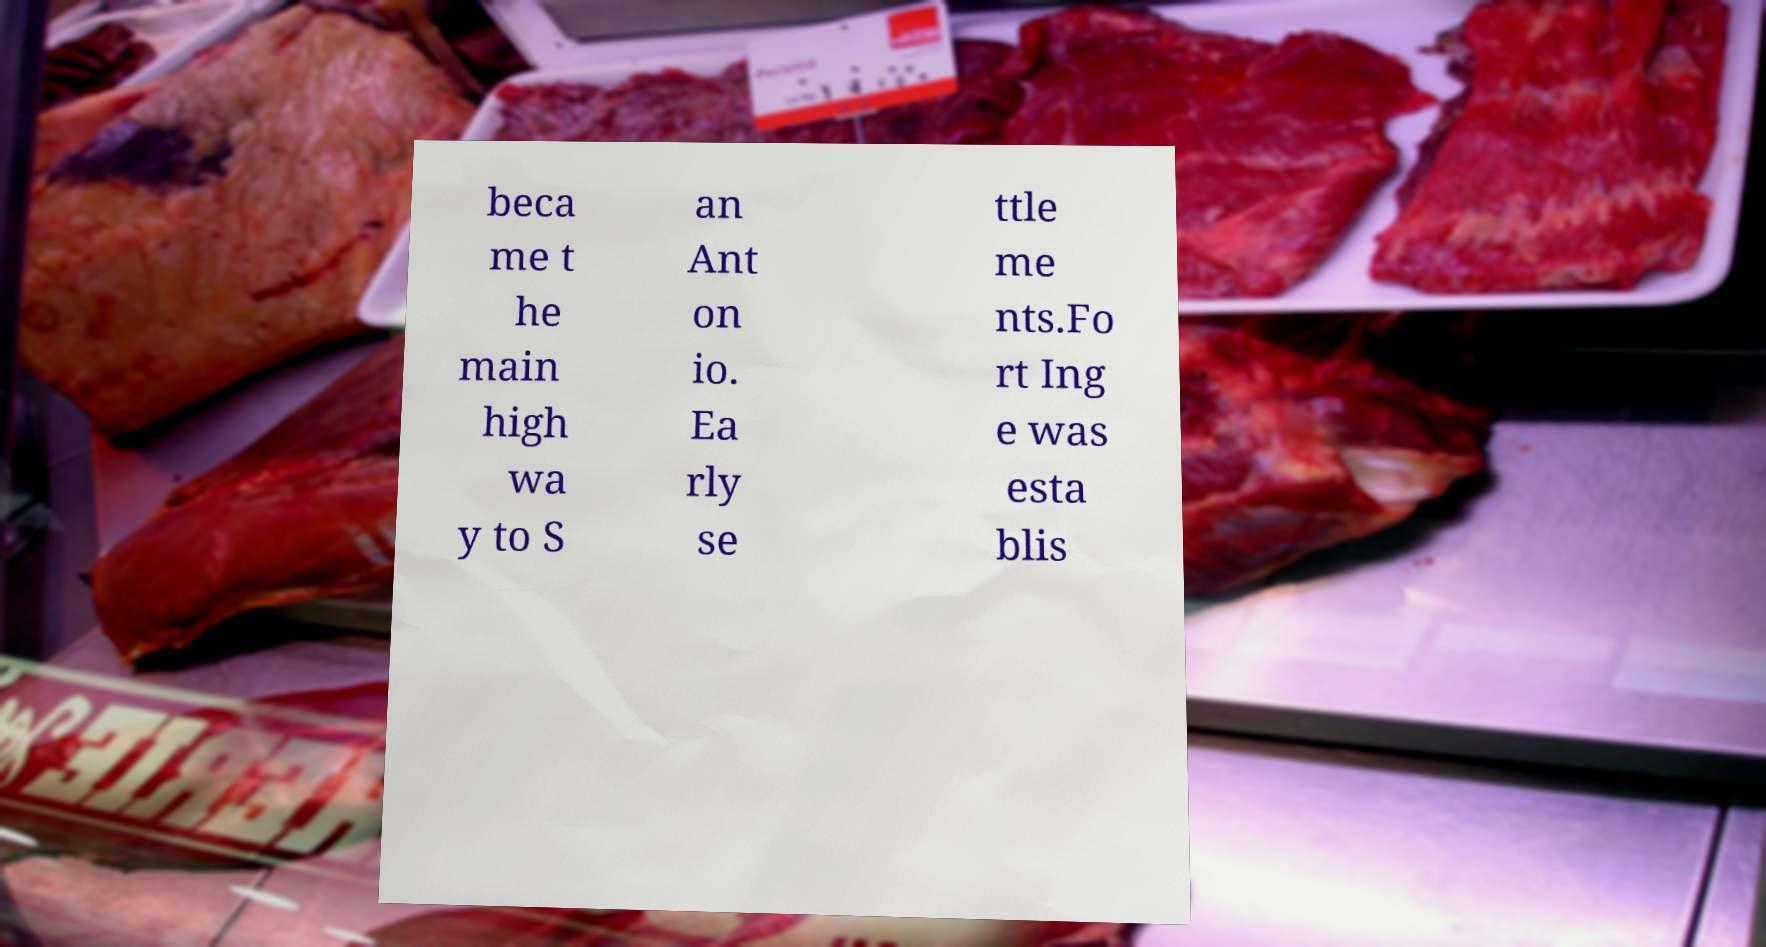Could you extract and type out the text from this image? beca me t he main high wa y to S an Ant on io. Ea rly se ttle me nts.Fo rt Ing e was esta blis 